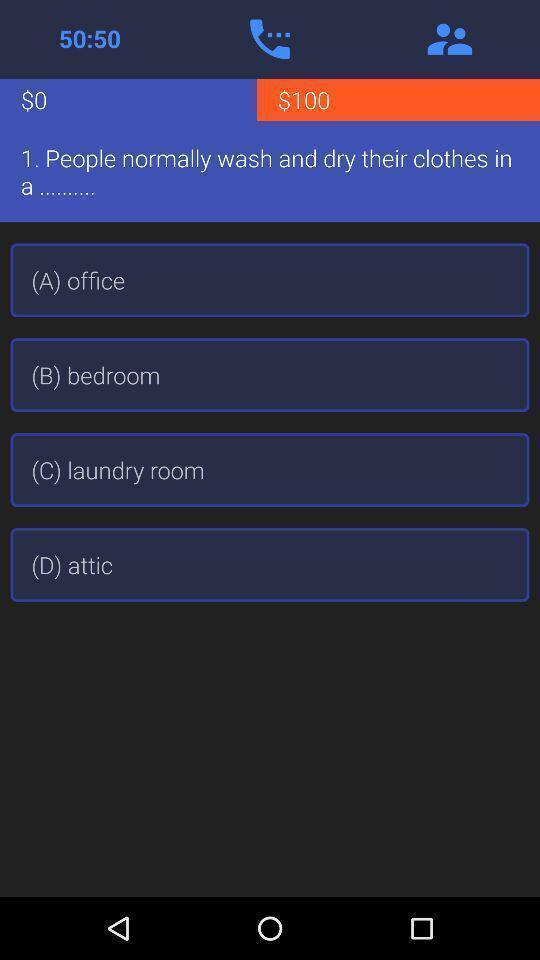Explain what's happening in this screen capture. Screen shows different options in a learning application. 